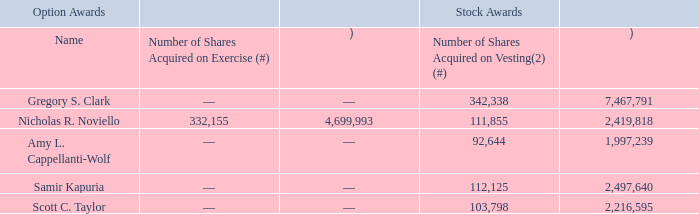The following table shows for the fiscal year ended March 29, 2019, certain information regarding option exercises and stock vested during the last fiscal year with respect to our named executive officers:
Option Exercises and Stock Vested in Fiscal 2019
(1) The value realized upon option exercises is based on the difference between the closing price of our common stock at exercise and the option exercise price.
(2) The number of shares and value realized for stock awards set forth above reflect (i) RSUs that vested and settled in FY19, (ii) RSUs granted under the FY19 EAIP on 5/20/2019, which vested and settled on 6/1/2019, and (iii) PRUs that vested in FY19 and were settled in FY20.
(3) The value realized upon vesting is based on the closing price of our common stock upon vesting in the case of RSUs and the closing price of our common stock on March 29, 2019 in the case of PRUs.
What does the table show? For the fiscal year ended march 29, 2019, certain information regarding option exercises and stock vested during the last fiscal year with respect to our named executive officers. What is value realized upon option exercises is based on? The difference between the closing price of our common stock at exercise and the option exercise price. What is the Value realized on vesting for stock awards for Scott C. Taylor? 2,216,595. What is the total value realized on vesting for stock awards for all named executive officers?  7,467,791+2,419,818+1,997,239+2,497,640+2,216,595
Answer: 16599083. What is the average total value realized on vesting for all named executive officers? (7,467,791+2,419,818+1,997,239+2,497,640+2,216,595)/5
Answer: 3319816.6. How much more shares acquired on vesting did Gregory S. Clark have over  Nicholas R. Noviello? 342,338-111,855
Answer: 230483. 